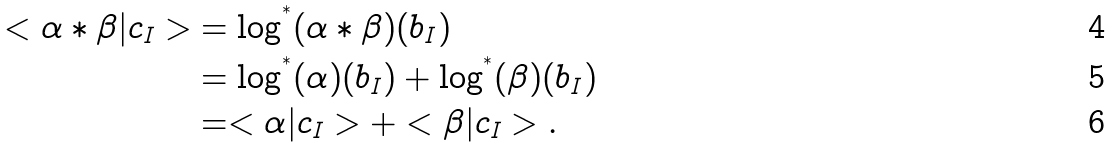<formula> <loc_0><loc_0><loc_500><loc_500>< \alpha \ast \beta | c _ { I } > & = \log ^ { ^ { * } } ( \alpha \ast \beta ) ( b _ { I } ) \\ & = \log ^ { ^ { * } } ( \alpha ) ( b _ { I } ) + \log ^ { ^ { * } } ( \beta ) ( b _ { I } ) \\ & = < \alpha | c _ { I } > + < \beta | c _ { I } > .</formula> 